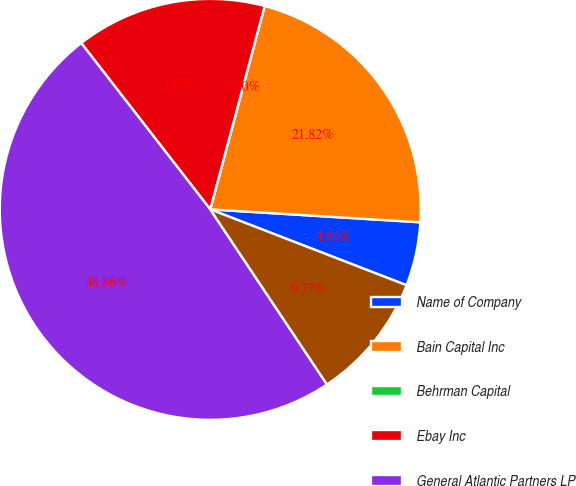Convert chart. <chart><loc_0><loc_0><loc_500><loc_500><pie_chart><fcel>Name of Company<fcel>Bain Capital Inc<fcel>Behrman Capital<fcel>Ebay Inc<fcel>General Atlantic Partners LP<fcel>Value Act Capital<nl><fcel>4.89%<fcel>21.82%<fcel>0.0%<fcel>14.66%<fcel>48.86%<fcel>9.77%<nl></chart> 